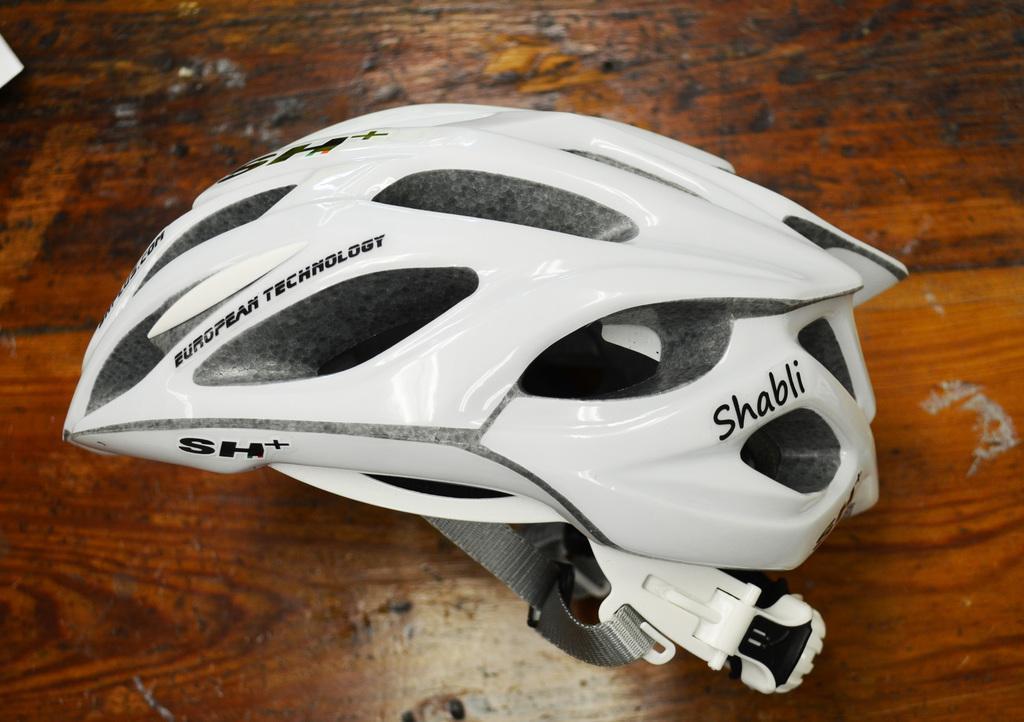How would you summarize this image in a sentence or two? As we can see in the image there is a table. On table there is a white color helmet. 